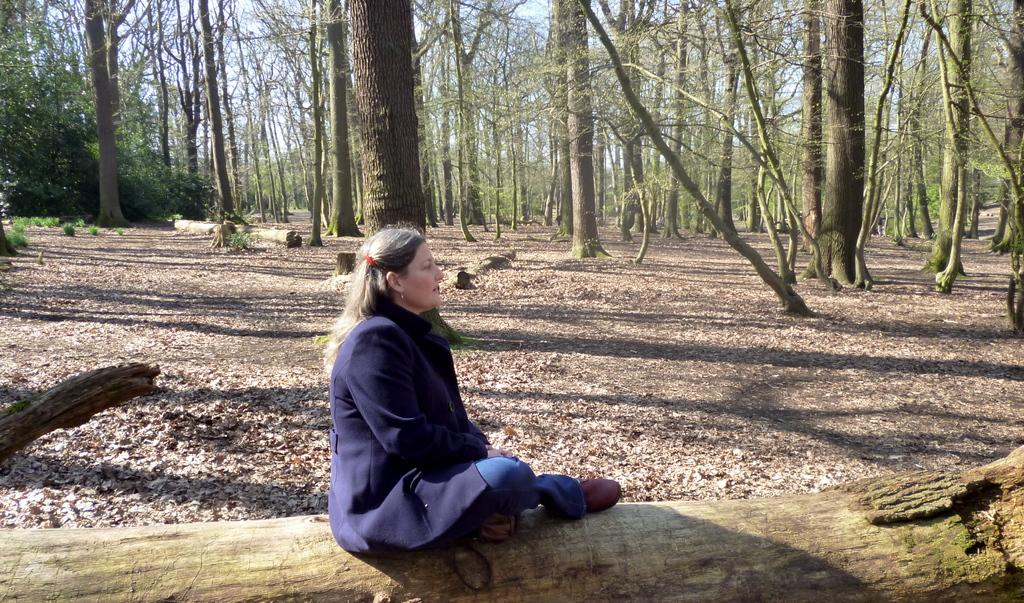Who is the main subject in the image? There is a lady in the image. What is the lady sitting on? The lady is sitting on a wooden trunk. What can be seen in the background of the image? There are many trees and the sky visible in the background of the image. Can you tell me how many grapes are on the lady's head in the image? There are no grapes present on the lady's head in the image. What type of kitten can be seen playing with a beetle in the image? There is no kitten or beetle present in the image. 